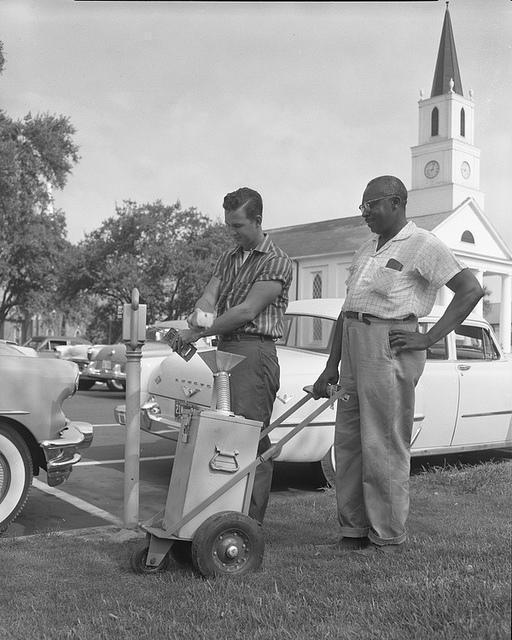How many cars are there?
Give a very brief answer. 3. How many people can be seen?
Give a very brief answer. 2. 